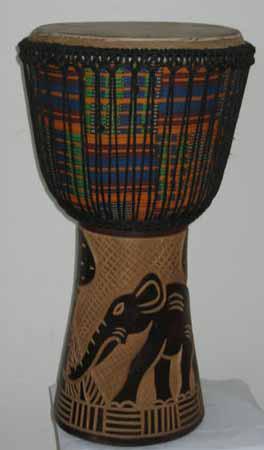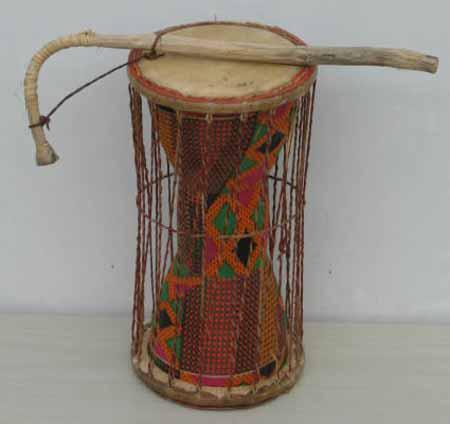The first image is the image on the left, the second image is the image on the right. Examine the images to the left and right. Is the description "There is a single drum in the left image and two drums in the right image." accurate? Answer yes or no. No. The first image is the image on the left, the second image is the image on the right. Given the left and right images, does the statement "In at least one image there are duel wooden drums." hold true? Answer yes or no. No. 